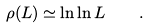<formula> <loc_0><loc_0><loc_500><loc_500>\rho ( L ) \simeq \ln \ln L \quad .</formula> 